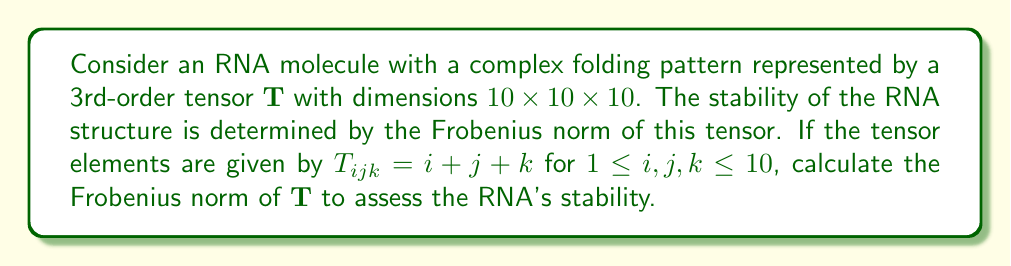Show me your answer to this math problem. To solve this problem, we'll follow these steps:

1) The Frobenius norm of a 3rd-order tensor is defined as:

   $$\|\mathbf{T}\|_F = \sqrt{\sum_{i=1}^{10}\sum_{j=1}^{10}\sum_{k=1}^{10} |T_{ijk}|^2}$$

2) We're given that $T_{ijk} = i + j + k$ for $1 \leq i,j,k \leq 10$

3) Let's expand the sum:

   $$\|\mathbf{T}\|_F^2 = \sum_{i=1}^{10}\sum_{j=1}^{10}\sum_{k=1}^{10} (i + j + k)^2$$

4) Expand the square:

   $$\|\mathbf{T}\|_F^2 = \sum_{i=1}^{10}\sum_{j=1}^{10}\sum_{k=1}^{10} (i^2 + j^2 + k^2 + 2ij + 2ik + 2jk)$$

5) We can separate this into six sums:

   $$\|\mathbf{T}\|_F^2 = \sum_{i=1}^{10}\sum_{j=1}^{10}\sum_{k=1}^{10} i^2 + \sum_{i=1}^{10}\sum_{j=1}^{10}\sum_{k=1}^{10} j^2 + \sum_{i=1}^{10}\sum_{j=1}^{10}\sum_{k=1}^{10} k^2 + 2\sum_{i=1}^{10}\sum_{j=1}^{10}\sum_{k=1}^{10} ij + 2\sum_{i=1}^{10}\sum_{j=1}^{10}\sum_{k=1}^{10} ik + 2\sum_{i=1}^{10}\sum_{j=1}^{10}\sum_{k=1}^{10} jk$$

6) Simplify each sum:
   
   - $\sum_{i=1}^{10}\sum_{j=1}^{10}\sum_{k=1}^{10} i^2 = 10^2 \cdot \sum_{i=1}^{10} i^2 = 10^2 \cdot \frac{10 \cdot 11 \cdot 21}{6} = 385000$
   - $\sum_{i=1}^{10}\sum_{j=1}^{10}\sum_{k=1}^{10} j^2 = 385000$
   - $\sum_{i=1}^{10}\sum_{j=1}^{10}\sum_{k=1}^{10} k^2 = 385000$
   - $2\sum_{i=1}^{10}\sum_{j=1}^{10}\sum_{k=1}^{10} ij = 2 \cdot 10 \cdot (\sum_{i=1}^{10} i)^2 = 2 \cdot 10 \cdot (55)^2 = 605000$
   - $2\sum_{i=1}^{10}\sum_{j=1}^{10}\sum_{k=1}^{10} ik = 605000$
   - $2\sum_{i=1}^{10}\sum_{j=1}^{10}\sum_{k=1}^{10} jk = 605000$

7) Sum all these terms:

   $$\|\mathbf{T}\|_F^2 = 385000 + 385000 + 385000 + 605000 + 605000 + 605000 = 2970000$$

8) Take the square root to get the Frobenius norm:

   $$\|\mathbf{T}\|_F = \sqrt{2970000} = 100\sqrt{297}$$
Answer: $100\sqrt{297}$ 